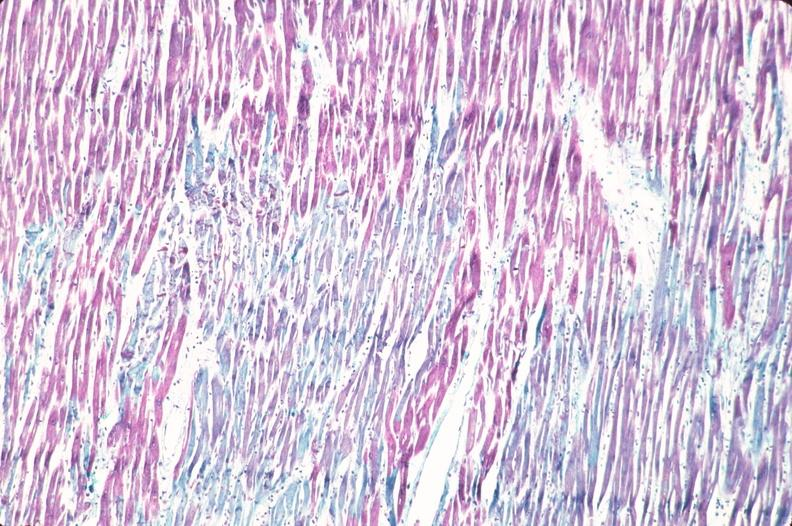what does this image show?
Answer the question using a single word or phrase. Heart 